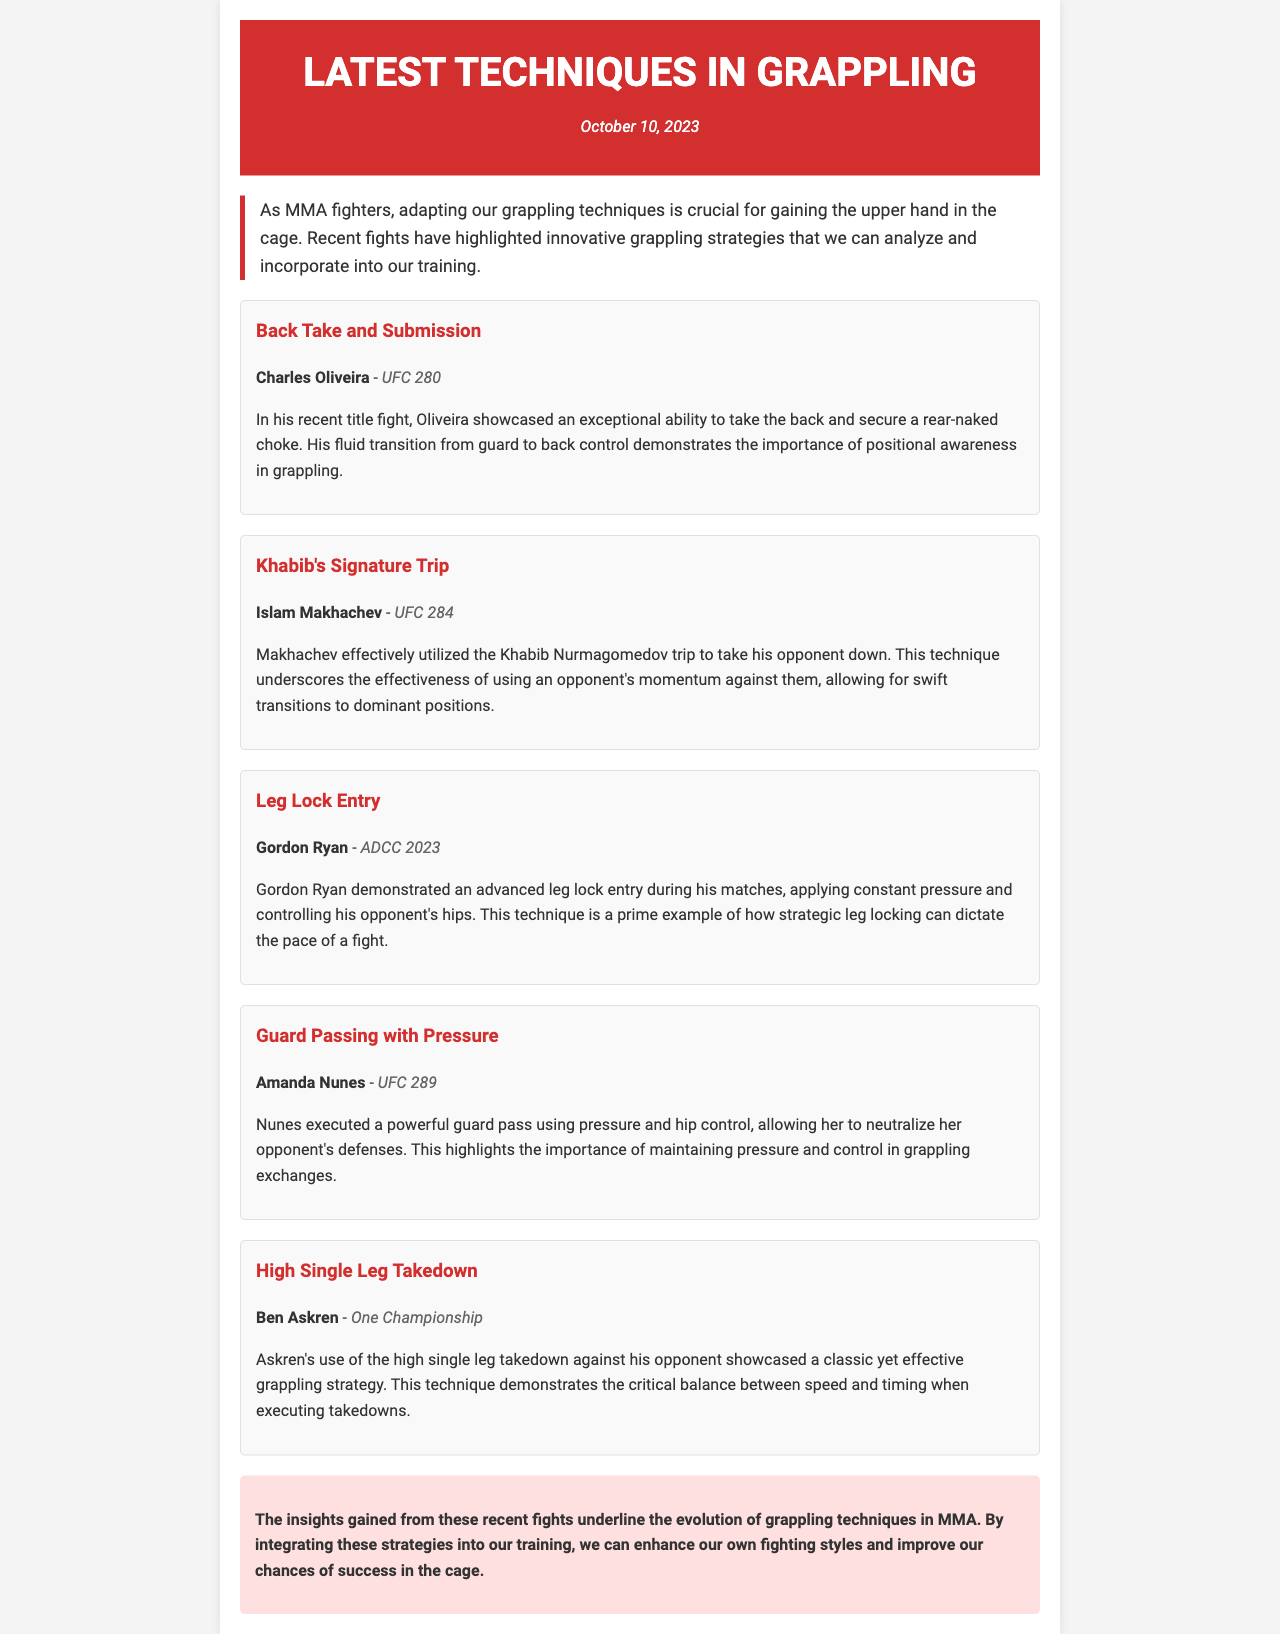What is the date of the newsletter? The date is mentioned at the top of the document under the header section.
Answer: October 10, 2023 Who showcased the back take and submission technique? The document specifically highlights Charles Oliveira for this technique.
Answer: Charles Oliveira What technique did Islam Makhachev use? The document states that Makhachev used Khabib's signature trip.
Answer: Khabib's Signature Trip What event did Gordon Ryan participate in? The specific event in which Gordon Ryan demonstrated the leg lock entry is mentioned.
Answer: ADCC 2023 What grappling technique did Amanda Nunes execute? The document notes that Nunes executed a powerful guard pass using pressure.
Answer: Guard Passing with Pressure How did Ben Askren's takedown technique categorize? The document categorizes Askren's takedown technique as a classic yet effective strategy.
Answer: High Single Leg Takedown What is emphasized as important during grappling exchanges? The document emphasizes the importance of maintaining pressure and control.
Answer: Pressure and control 